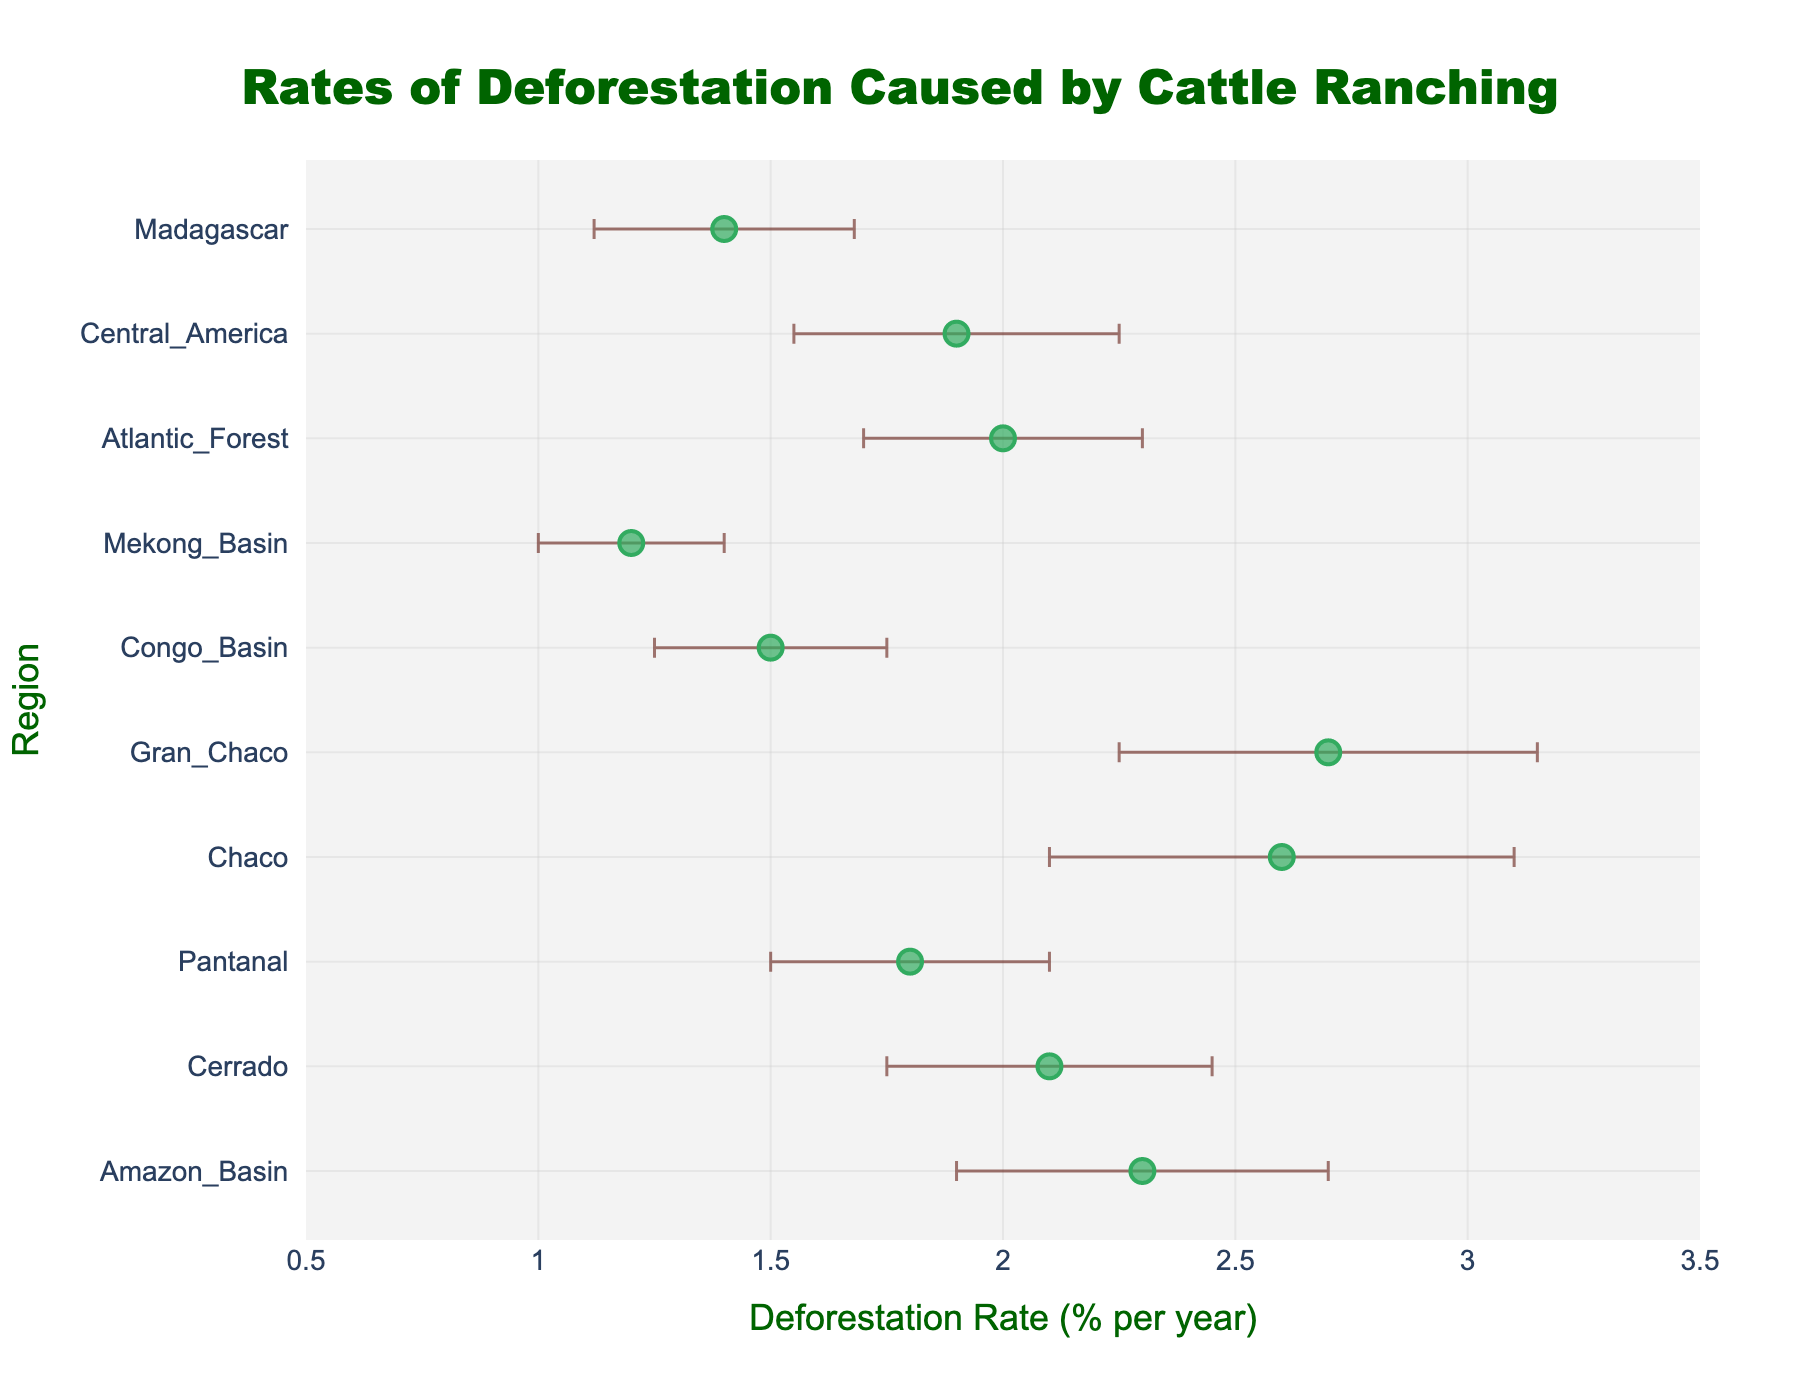What's the title of the figure? The title is usually displayed at the top and describes the content of the plot. In this case, it specifies the topic.
Answer: Rates of Deforestation Caused by Cattle Ranching What does the x-axis represent? The x-axis is labeled and shows one of the key variables being plotted. In this figure, it represents the rate of deforestation per year.
Answer: Deforestation Rate (% per year) Which region has the highest rate of deforestation? To find this, look for the rightmost dot on the plot; that will indicate the highest value on the x-axis.
Answer: Gran Chaco What is the deforestation rate for Central America? Locate the dot associated with Central America on the y-axis, and then read its position on the x-axis.
Answer: 1.9 What are the standard deviation values shown as on this plot? In a dot plot with error bars, the error bars represent the standard deviation values for each data point.
Answer: Error bars Which regions have deforestation rates greater than 2% per year? Identify the dots to the right of the 2% mark on the x-axis and list the corresponding regions on the y-axis.
Answer: Amazon Basin, Cerrado, Chaco, Gran Chaco, Atlantic Forest What's the difference in deforestation rates between the Amazon Basin and the Mekong Basin? Subtract the deforestation rate of the Mekong Basin from that of the Amazon Basin. 2.3 - 1.2 = 1.1%
Answer: 1.1% How does the standard deviation for Chaco compare to that for Cerrado? Compare the length of the error bars for Chaco and Cerrado. Longer error bars indicate higher standard deviations.
Answer: Chaco has a higher standard deviation Which region has the smallest deforestation rate? Locate the leftmost dot on the plot, which represents the smallest value on the x-axis.
Answer: Mekong Basin What can you infer about the deforestation rates of the Amazon Basin and the Atlantic Forest? Both regions have similar deforestation rates; compare their x-axis coordinates and the length of the error bars to discuss variability.
Answer: Both have rates around 2%, but the Amazon Basin shows more variability 